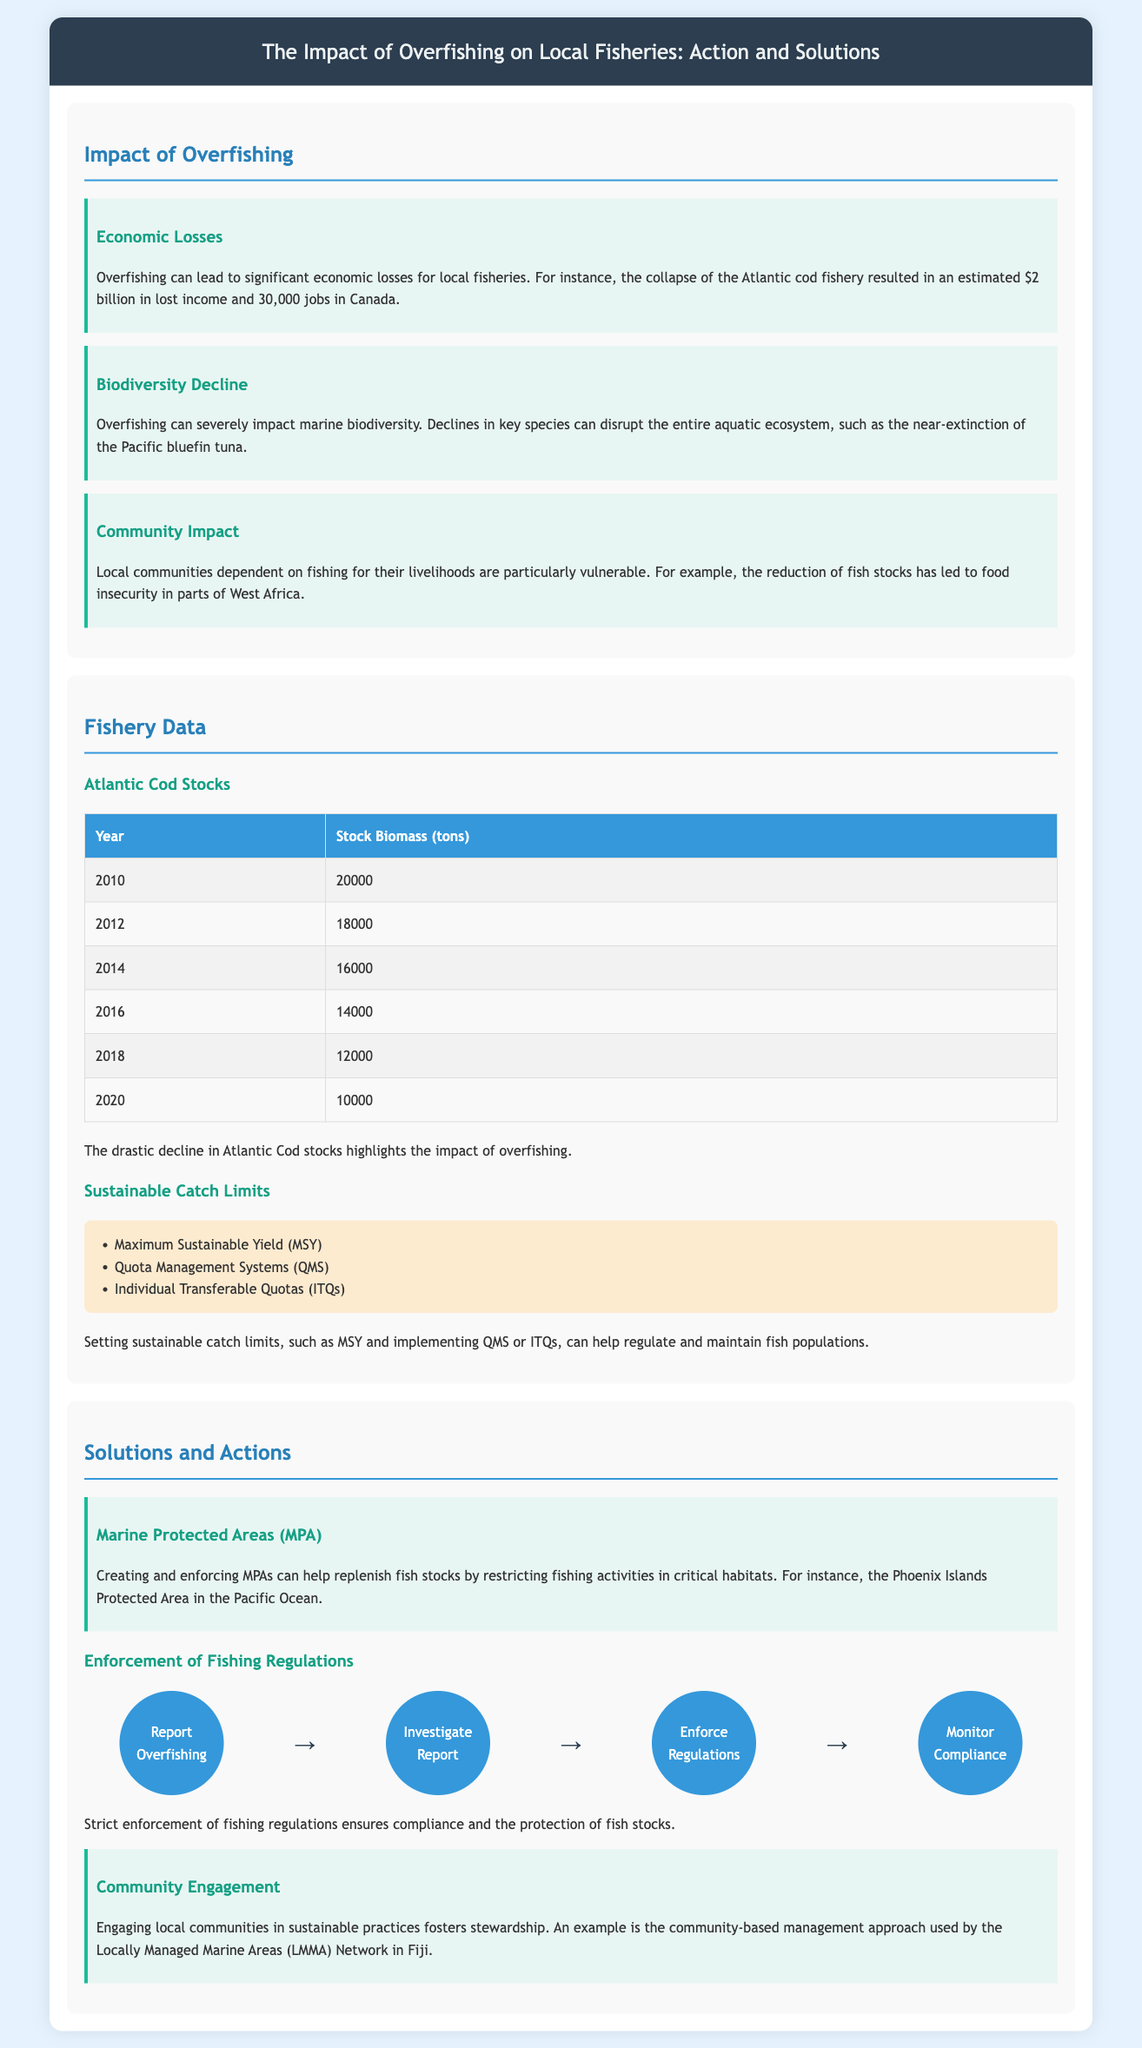What is the estimated economic loss from the collapse of the Atlantic cod fishery? The estimated economic loss from the collapse of the Atlantic cod fishery is $2 billion.
Answer: $2 billion What is the stock biomass of Atlantic Cod in 2018? The stock biomass of Atlantic Cod in 2018 is recorded in the data table.
Answer: 12000 Which type of marine area can help replenish fish stocks? The document suggests creating and enforcing a specific type of area to help replenish fish stocks.
Answer: Marine Protected Areas What approach is used by the Locally Managed Marine Areas (LMMA) Network in Fiji? The document provides information about the approach taken by the LMMA Network to engage local communities.
Answer: Community-based management In what year was the stock biomass of Atlantic Cod last recorded at 10000 tons? The year corresponding to the given stock biomass can be found in the data table.
Answer: 2020 What are Individual Transferable Quotas (ITQs) categorized under? The document categorizes ITQs under a specific type of limits listed for fisheries.
Answer: Sustainable Catch Limits What is the first action in the enforcement flowchart? The flowchart outlines a series of actions. The first action is clearly stated.
Answer: Report Overfishing What led to food insecurity in parts of West Africa? The document states a specific cause for food insecurity in these regions.
Answer: Reduction of fish stocks 